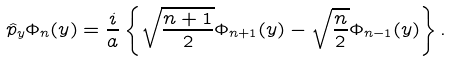Convert formula to latex. <formula><loc_0><loc_0><loc_500><loc_500>\hat { p } _ { y } \Phi _ { n } ( y ) = \frac { i } { a } \left \{ \sqrt { \frac { n + 1 } { 2 } } \Phi _ { n + 1 } ( y ) - \sqrt { \frac { n } { 2 } } \Phi _ { n - 1 } ( y ) \right \} .</formula> 